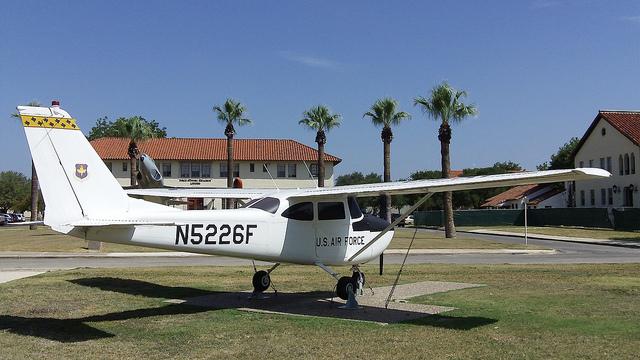Is this an Army or Air Force plane?
Be succinct. Air force. What color is the broken jet?
Concise answer only. White. Where is this?
Answer briefly. Florida. What is written on the plane?
Write a very short answer. Us air force. What number is this plane?
Concise answer only. N5226f. What kind of trees are in the background?
Concise answer only. Palm. 